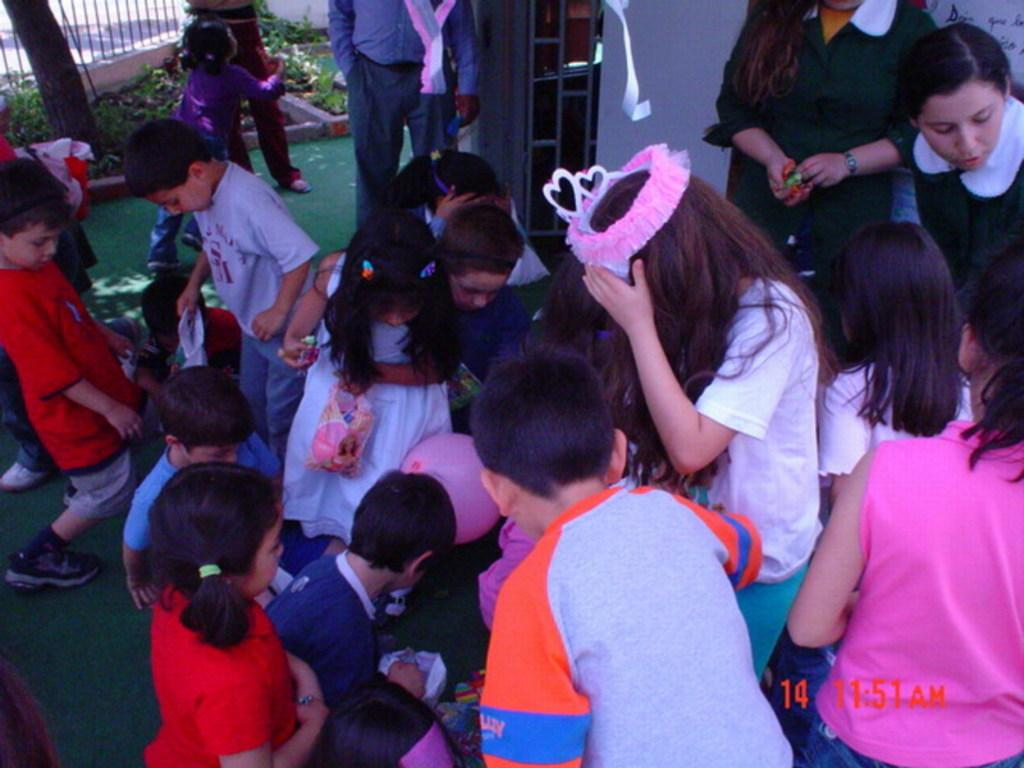What can be seen in the image involving young individuals? There is a group of children in the image. Are there any adults present in the image? Yes, there are persons visible in the image. What is located at the top of the image? There is a fence at the top of the image. What type of living organisms can be seen in the image? Plants are present in the image. What type of bucket is being used by the owner in the image? There is no bucket or owner present in the image. 